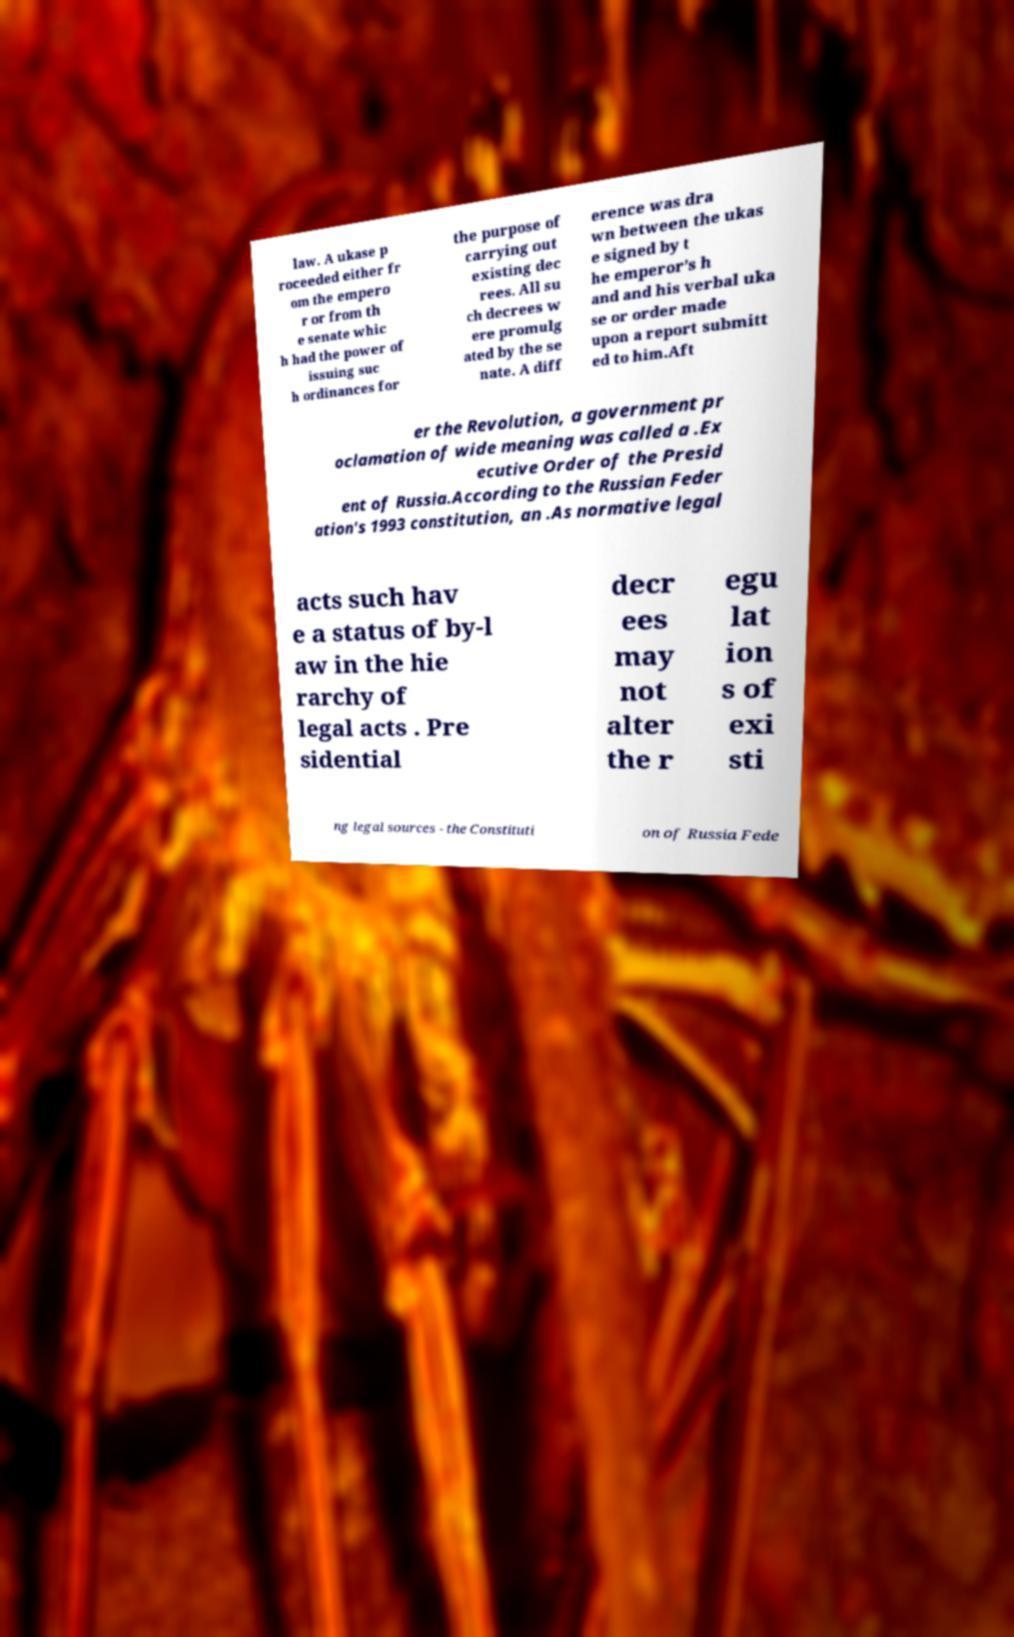Please identify and transcribe the text found in this image. law. A ukase p roceeded either fr om the empero r or from th e senate whic h had the power of issuing suc h ordinances for the purpose of carrying out existing dec rees. All su ch decrees w ere promulg ated by the se nate. A diff erence was dra wn between the ukas e signed by t he emperor’s h and and his verbal uka se or order made upon a report submitt ed to him.Aft er the Revolution, a government pr oclamation of wide meaning was called a .Ex ecutive Order of the Presid ent of Russia.According to the Russian Feder ation's 1993 constitution, an .As normative legal acts such hav e a status of by-l aw in the hie rarchy of legal acts . Pre sidential decr ees may not alter the r egu lat ion s of exi sti ng legal sources - the Constituti on of Russia Fede 